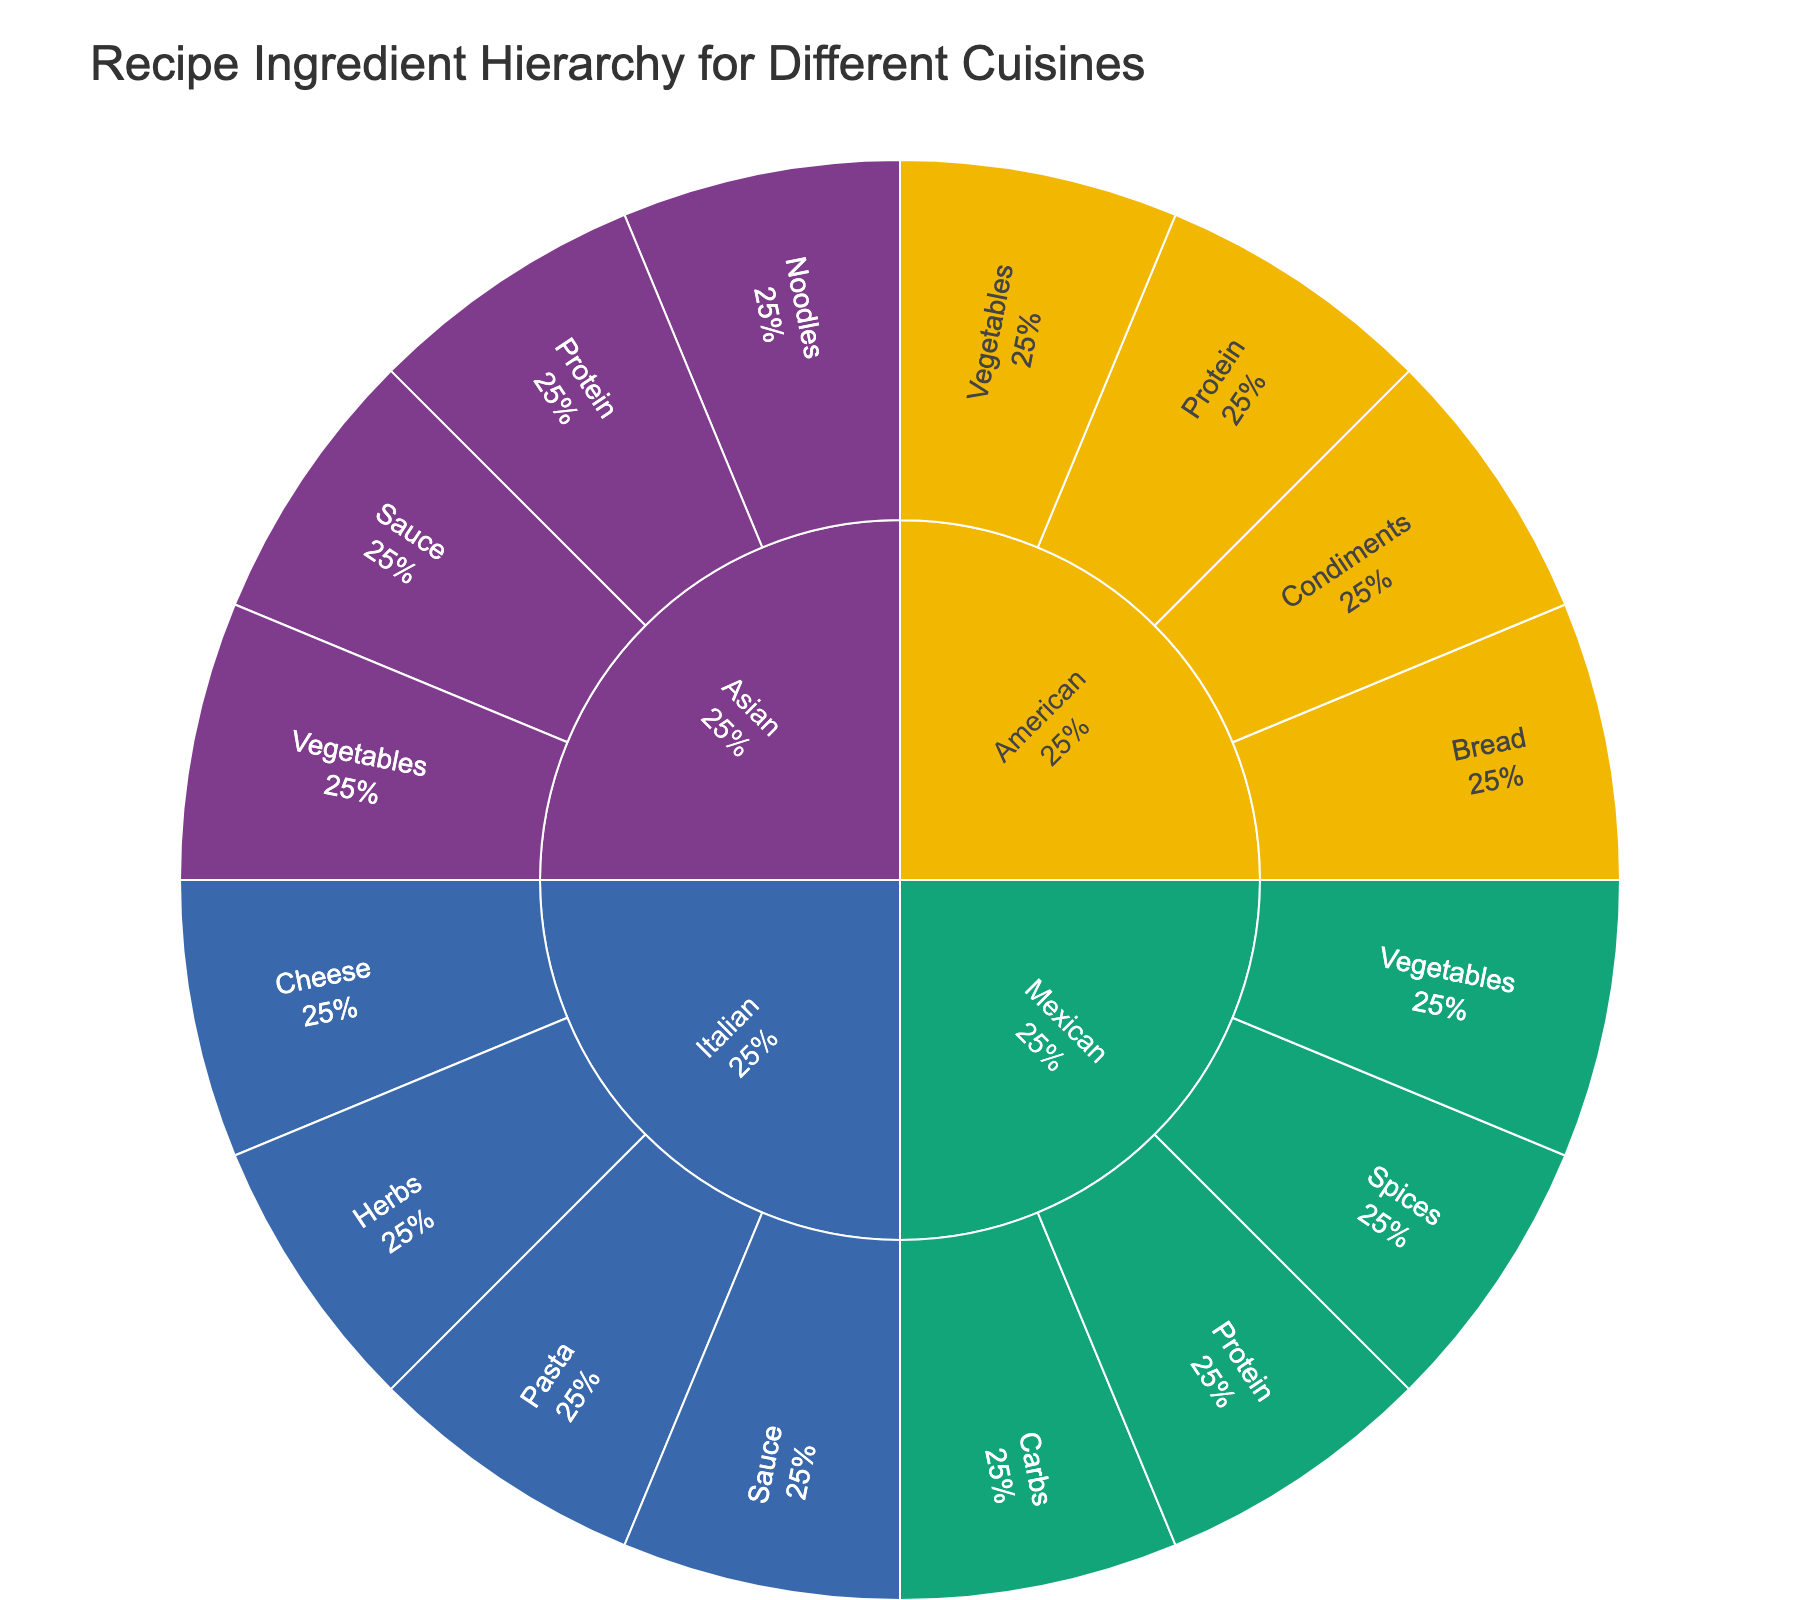What's the title of the figure? The title is positioned at the top of the figure. It provides an overall description of what the visual represents.
Answer: Recipe Ingredient Hierarchy for Different Cuisines How many main cuisines are represented in the plot? To find the number of main cuisines, look at the outermost circle, which denotes the categories. Count the unique segments.
Answer: 4 Which category has the most subcategories? To determine this, check the different segments branching out from each main cuisine category and count the subcategories per cuisine.
Answer: Italian Which Italian subcategory has the most ingredients? Within the Italian category, count the ingredients under each subcategory by looking at the inner ring segments corresponding to each subcategory.
Answer: Pasta How many ingredients are listed under the Mexican category? Look at the size and number of segments branching from the Mexican category. Count all the ingredients in those segments.
Answer: 8 What percentage of the Italian subcategory is represented by Cheese? Find the Cheese subcategory under Italian and look at its segment. The plot should show the percentage of its parent (Italian category).
Answer: 33% Which ingredients are common between Mexican and American cuisines? Compare the ingredients listed under each subcategory for Mexican and American cuisines to identify any overlaps.
Answer: Chicken Which cuisine category contains Shrimp? Locate Shrimp by scanning through the inner ring of ingredients, and identify the corresponding outer ring category.
Answer: Asian Which cuisine has Tortillas as an ingredient? Scan for Tortillas in the inner ring of ingredients and identify the corresponding outer ring category.
Answer: Mexican Between Asian and American cuisines, which has more different types of subcategories? Count the different subcategories under the Asian and American sections and compare their numbers.
Answer: Asian 